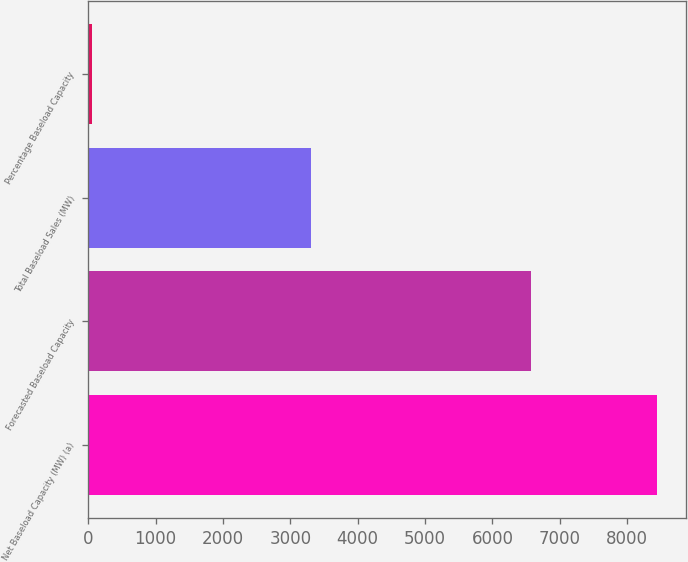Convert chart. <chart><loc_0><loc_0><loc_500><loc_500><bar_chart><fcel>Net Baseload Capacity (MW) (a)<fcel>Forecasted Baseload Capacity<fcel>Total Baseload Sales (MW)<fcel>Percentage Baseload Capacity<nl><fcel>8450<fcel>6569<fcel>3310<fcel>50<nl></chart> 